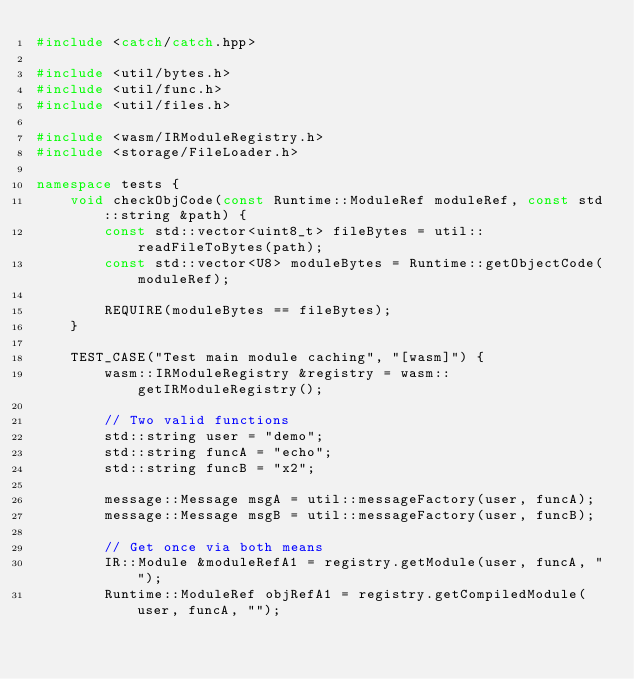<code> <loc_0><loc_0><loc_500><loc_500><_C++_>#include <catch/catch.hpp>

#include <util/bytes.h>
#include <util/func.h>
#include <util/files.h>

#include <wasm/IRModuleRegistry.h>
#include <storage/FileLoader.h>

namespace tests {
    void checkObjCode(const Runtime::ModuleRef moduleRef, const std::string &path) {
        const std::vector<uint8_t> fileBytes = util::readFileToBytes(path);
        const std::vector<U8> moduleBytes = Runtime::getObjectCode(moduleRef);

        REQUIRE(moduleBytes == fileBytes);
    }

    TEST_CASE("Test main module caching", "[wasm]") {
        wasm::IRModuleRegistry &registry = wasm::getIRModuleRegistry();

        // Two valid functions
        std::string user = "demo";
        std::string funcA = "echo";
        std::string funcB = "x2";

        message::Message msgA = util::messageFactory(user, funcA);
        message::Message msgB = util::messageFactory(user, funcB);

        // Get once via both means
        IR::Module &moduleRefA1 = registry.getModule(user, funcA, "");
        Runtime::ModuleRef objRefA1 = registry.getCompiledModule(user, funcA, "");</code> 